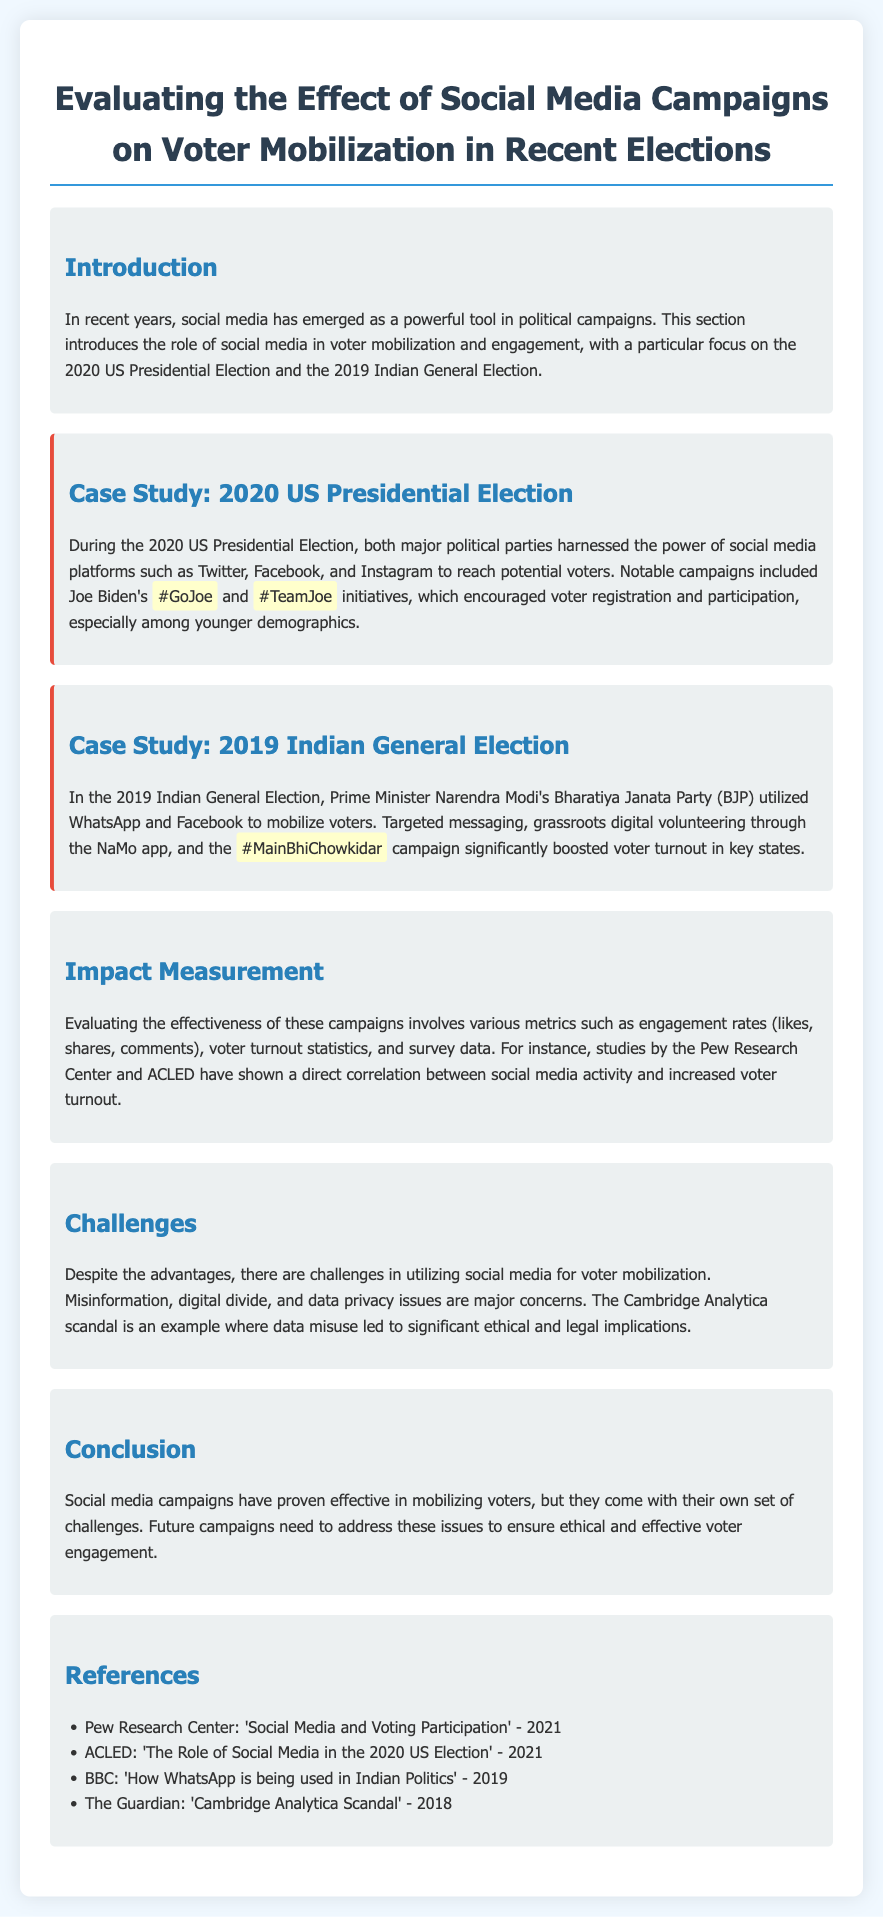what year was the US Presidential Election discussed in the document? The document mentions the 2020 US Presidential Election as a significant event related to social media campaigns for voter mobilization.
Answer: 2020 which campaigns are highlighted in the case study about the US Presidential Election? The case study mentions Joe Biden's #GoJoe and #TeamJoe initiatives as key campaigns in the 2020 US Presidential Election.
Answer: #GoJoe and #TeamJoe what social media platforms were utilized in the 2019 Indian General Election? The document specifies that WhatsApp and Facebook were the primary platforms used by the BJP for mobilizing voters in the 2019 Indian General Election.
Answer: WhatsApp and Facebook what was a significant result of Modi's social media efforts in the 2019 Indian General Election? The document states that these efforts, including targeted messaging and a specific campaign, significantly boosted voter turnout in key states.
Answer: boosted voter turnout which organization conducted studies showing a correlation between social media activity and voter turnout? The document mentions the Pew Research Center as one of the organizations that studied this correlation.
Answer: Pew Research Center what is one major challenge of using social media for voter mobilization as highlighted in the document? The document emphasizes misinformation as a significant challenge in utilizing social media for voter mobilization.
Answer: misinformation what does the conclusion suggest about future social media campaigns? The conclusion indicates that future campaigns need to address challenges to ensure ethical and effective voter engagement.
Answer: address challenges how was voter engagement measured in the context of social media campaigns? The document outlines the use of metrics like engagement rates, voter turnout statistics, and survey data to measure voter engagement.
Answer: engagement rates, voter turnout statistics, and survey data 